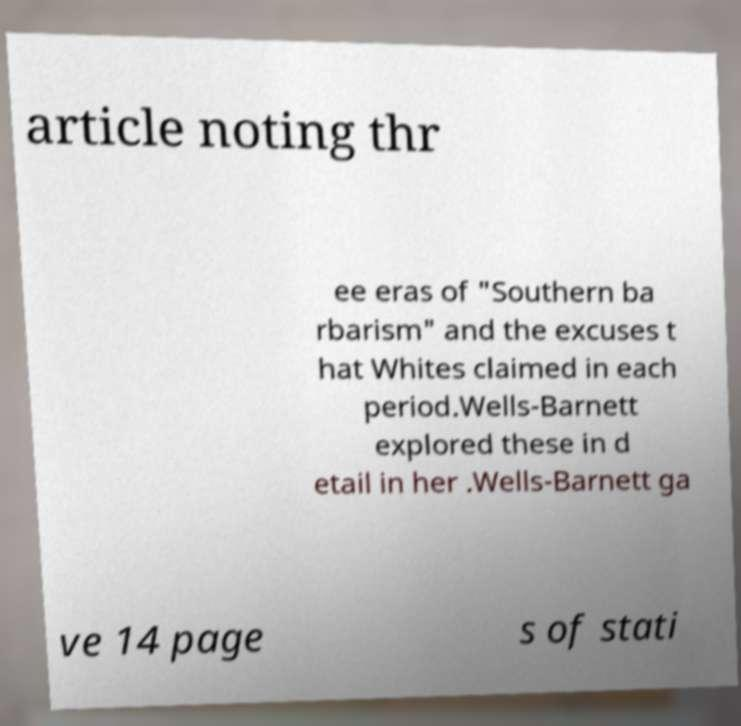Please identify and transcribe the text found in this image. article noting thr ee eras of "Southern ba rbarism" and the excuses t hat Whites claimed in each period.Wells-Barnett explored these in d etail in her .Wells-Barnett ga ve 14 page s of stati 